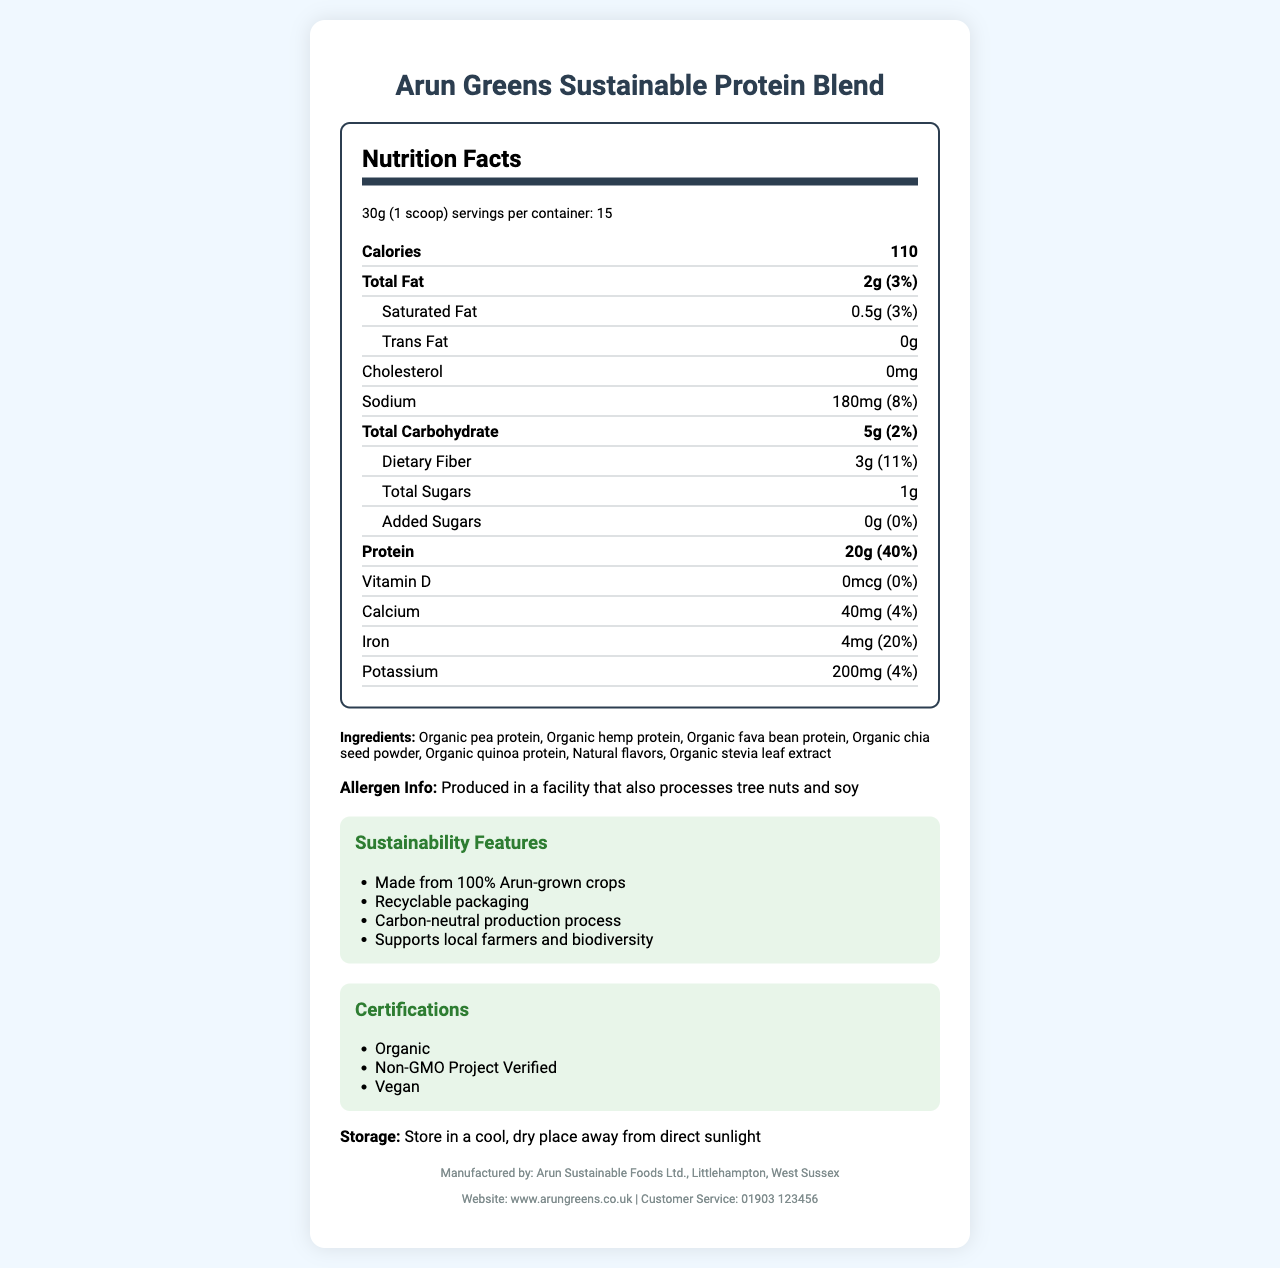what is the serving size? The serving size is specified in the nutrition facts label as 30g (1 scoop).
Answer: 30g (1 scoop) how many servings are there per container? The nutrition facts label states that there are 15 servings per container.
Answer: 15 how many calories are there per serving? The nutrition facts label indicates that there are 110 calories per serving.
Answer: 110 what is the total fat content per serving? The nutrition facts label lists the total fat content as 2g per serving, which is 3% of the daily value.
Answer: 2g (3%) what are the main ingredients? The ingredients section lists these as the main components of the protein powder.
Answer: Organic pea protein, Organic hemp protein, Organic fava bean protein, Organic chia seed powder, Organic quinoa protein, Natural flavors, Organic stevia leaf extract how much protein is in each serving? The nutrition facts label specifies that there are 20g of protein per serving, which is 40% of the daily value.
Answer: 20g (40%) what is the amount of dietary fiber per serving? The nutrition facts label shows that there are 3g of dietary fiber per serving, constituting 11% of the daily value.
Answer: 3g (11%) how many grams of added sugars does the product contain? The nutrition facts label indicates that the product contains 0g of added sugars, which is 0% of the daily value.
Answer: 0g (0%) what is the source of protein in the product? These are listed in the ingredients section as the sources of protein.
Answer: Organic pea protein, Organic hemp protein, Organic fava bean protein, Organic quinoa protein what is the sustainability feature of the packaging? The sustainability section mentions that the product has recyclable packaging.
Answer: Recyclable packaging The product should be stored in which conditions? The storage instructions advise storing the product in a cool, dry place away from direct sunlight.
Answer: In a cool, dry place away from direct sunlight which certification is not mentioned for the product? A. Organic B. Non-GMO Project Verified C. Gluten-Free The certifications listed are Organic, Non-GMO Project Verified, and Vegan. Gluten-Free is not mentioned.
Answer: C how much sodium is in each serving? The nutrition facts label specifies that there are 180mg of sodium per serving, which is 8% of the daily value.
Answer: 180mg (8%) is the production process carbon-neutral? The sustainability section indicates that the production process is carbon-neutral.
Answer: Yes does the product contain any artificial flavors? The ingredients list states "Natural flavors," indicating no artificial flavors are included.
Answer: No who manufactures the product and where are they located? The footer of the document provides the manufacturer's name and location.
Answer: Arun Sustainable Foods Ltd., Littlehampton, West Sussex which allergen information is provided? The document includes an allergen information statement indicating that the product is produced in a facility that also processes tree nuts and soy.
Answer: Produced in a facility that also processes tree nuts and soy does the product contain any cholesterol? The nutrition facts label indicates that there is 0mg of cholesterol in the product.
Answer: No which of the following nutrients does the product not contain? A. Calcium B. Vitamin D C. Iron D. Potassium The nutrition facts label shows 0mcg of Vitamin D, whereas other nutrients such as Calcium, Iron, and Potassium have specified amounts.
Answer: B how supportive is the product of local Arun farmers? The sustainability features mention that the product supports local farmers and biodiversity.
Answer: Supports local farmers and biodiversity what is the main idea of the document? The document details the nutritional benefits, ingredients, sustainability aspects, and certifications of the Arun Greens Sustainable Protein Blend, aimed at informing consumers about the product's health and environmental benefits.
Answer: The document provides detailed information about the Arun Greens Sustainable Protein Blend, including its nutritional values, ingredients, sustainability features, and certifications. what is the protein source for Arun Greens Sustainable Protein Blend? The document does not provide specific details about the exact source of the organic proteins used; it only lists them as Organic pea protein, Organic hemp protein, etc.
Answer: Cannot be determined 